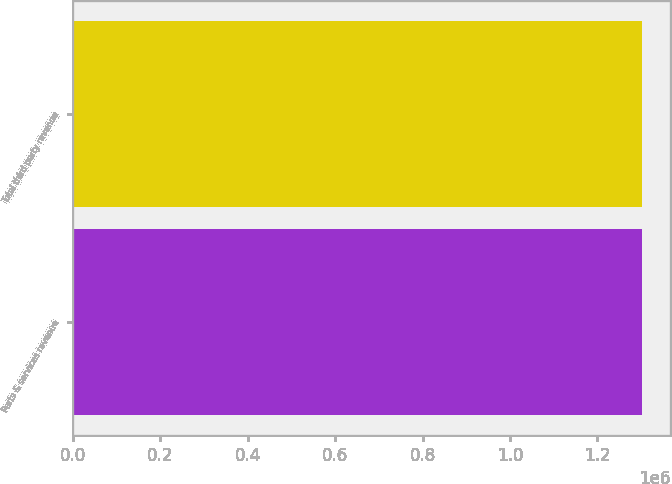Convert chart. <chart><loc_0><loc_0><loc_500><loc_500><bar_chart><fcel>Parts & services revenue<fcel>Total third party revenue<nl><fcel>1.3012e+06<fcel>1.3012e+06<nl></chart> 